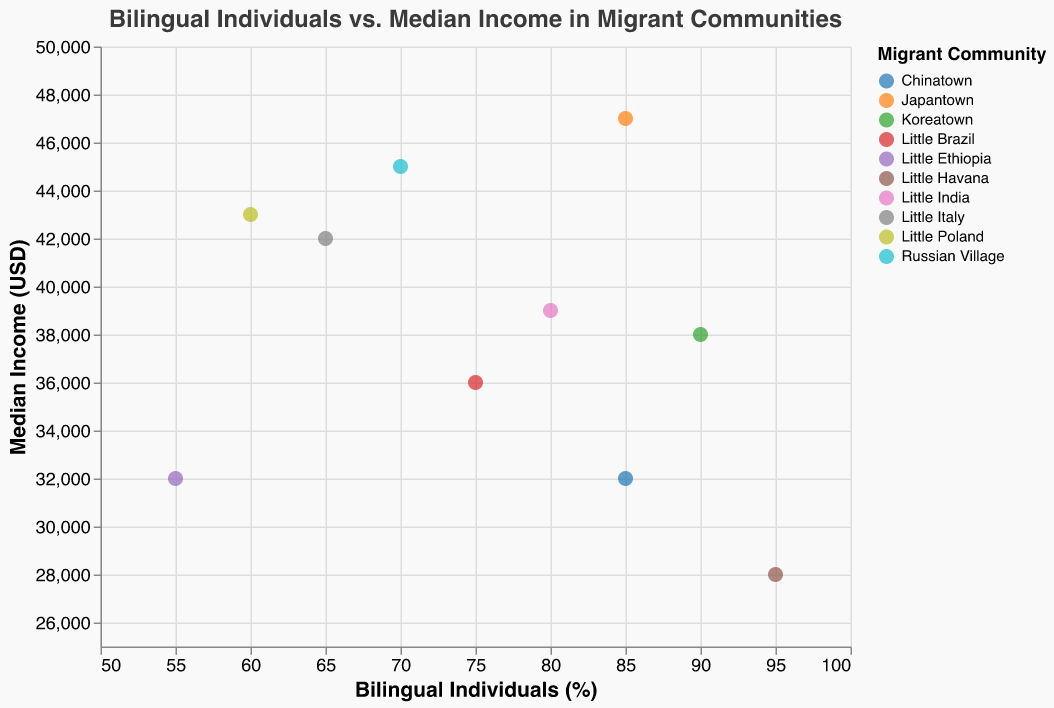What is the title of the figure? The title of the figure is displayed at the top of the chart, indicated by larger text and centered alignment. It reads "Bilingual Individuals vs. Median Income in Migrant Communities."
Answer: Bilingual Individuals vs. Median Income in Migrant Communities How many communities are represented in the scatter plot? The data values section lists ten different communities. Each community corresponds to a unique colored point in the scatter plot.
Answer: 10 Which community has the highest percentage of bilingual individuals? By examining the x-axis, which represents the percentage of bilingual individuals, the point furthest to the right corresponds to Little Havana which has 95%.
Answer: Little Havana Which community has the highest median income? By looking at the y-axis which represents median income, the point highest on the y-axis corresponds to Japantown with $47,000.
Answer: Japantown What is the median income for Chinatown? Hovering over or identifying the point labeled "Chinatown" in the plot indicates a median income of $32,000.
Answer: $32,000 How does the median income of Little Havana compare to that of Little Italy? Little Havana has a median income of $28,000, while Little Italy has a median income of $42,000. Therefore, Little Italy has a higher median income than Little Havana.
Answer: Little Italy has higher Which community has a higher percentage of bilingual individuals: Little Brazil or Little Poland? The x-axis shows the percentage of bilingual individuals. Little Brazil is at 75% while Little Poland is at 60%. Hence, Little Brazil has a higher percentage.
Answer: Little Brazil What is the average median income across all communities? Summing all the median incomes listed ($32,000, $42,000, $38,000, $32,000, $45,000, $39,000, $36,000, $28,000, $47,000, $43,000) results in $382,000. Dividing by 10 gives an average median income of $38,200.
Answer: $38,200 Are there communities where both the percentage of bilingual individuals and median income are relatively high? Communities such as Japantown (85%, $47,000) and Russian Village (70%, $45,000) show high values in both parameters compared to others.
Answer: Yes, Japantown and Russian Village 